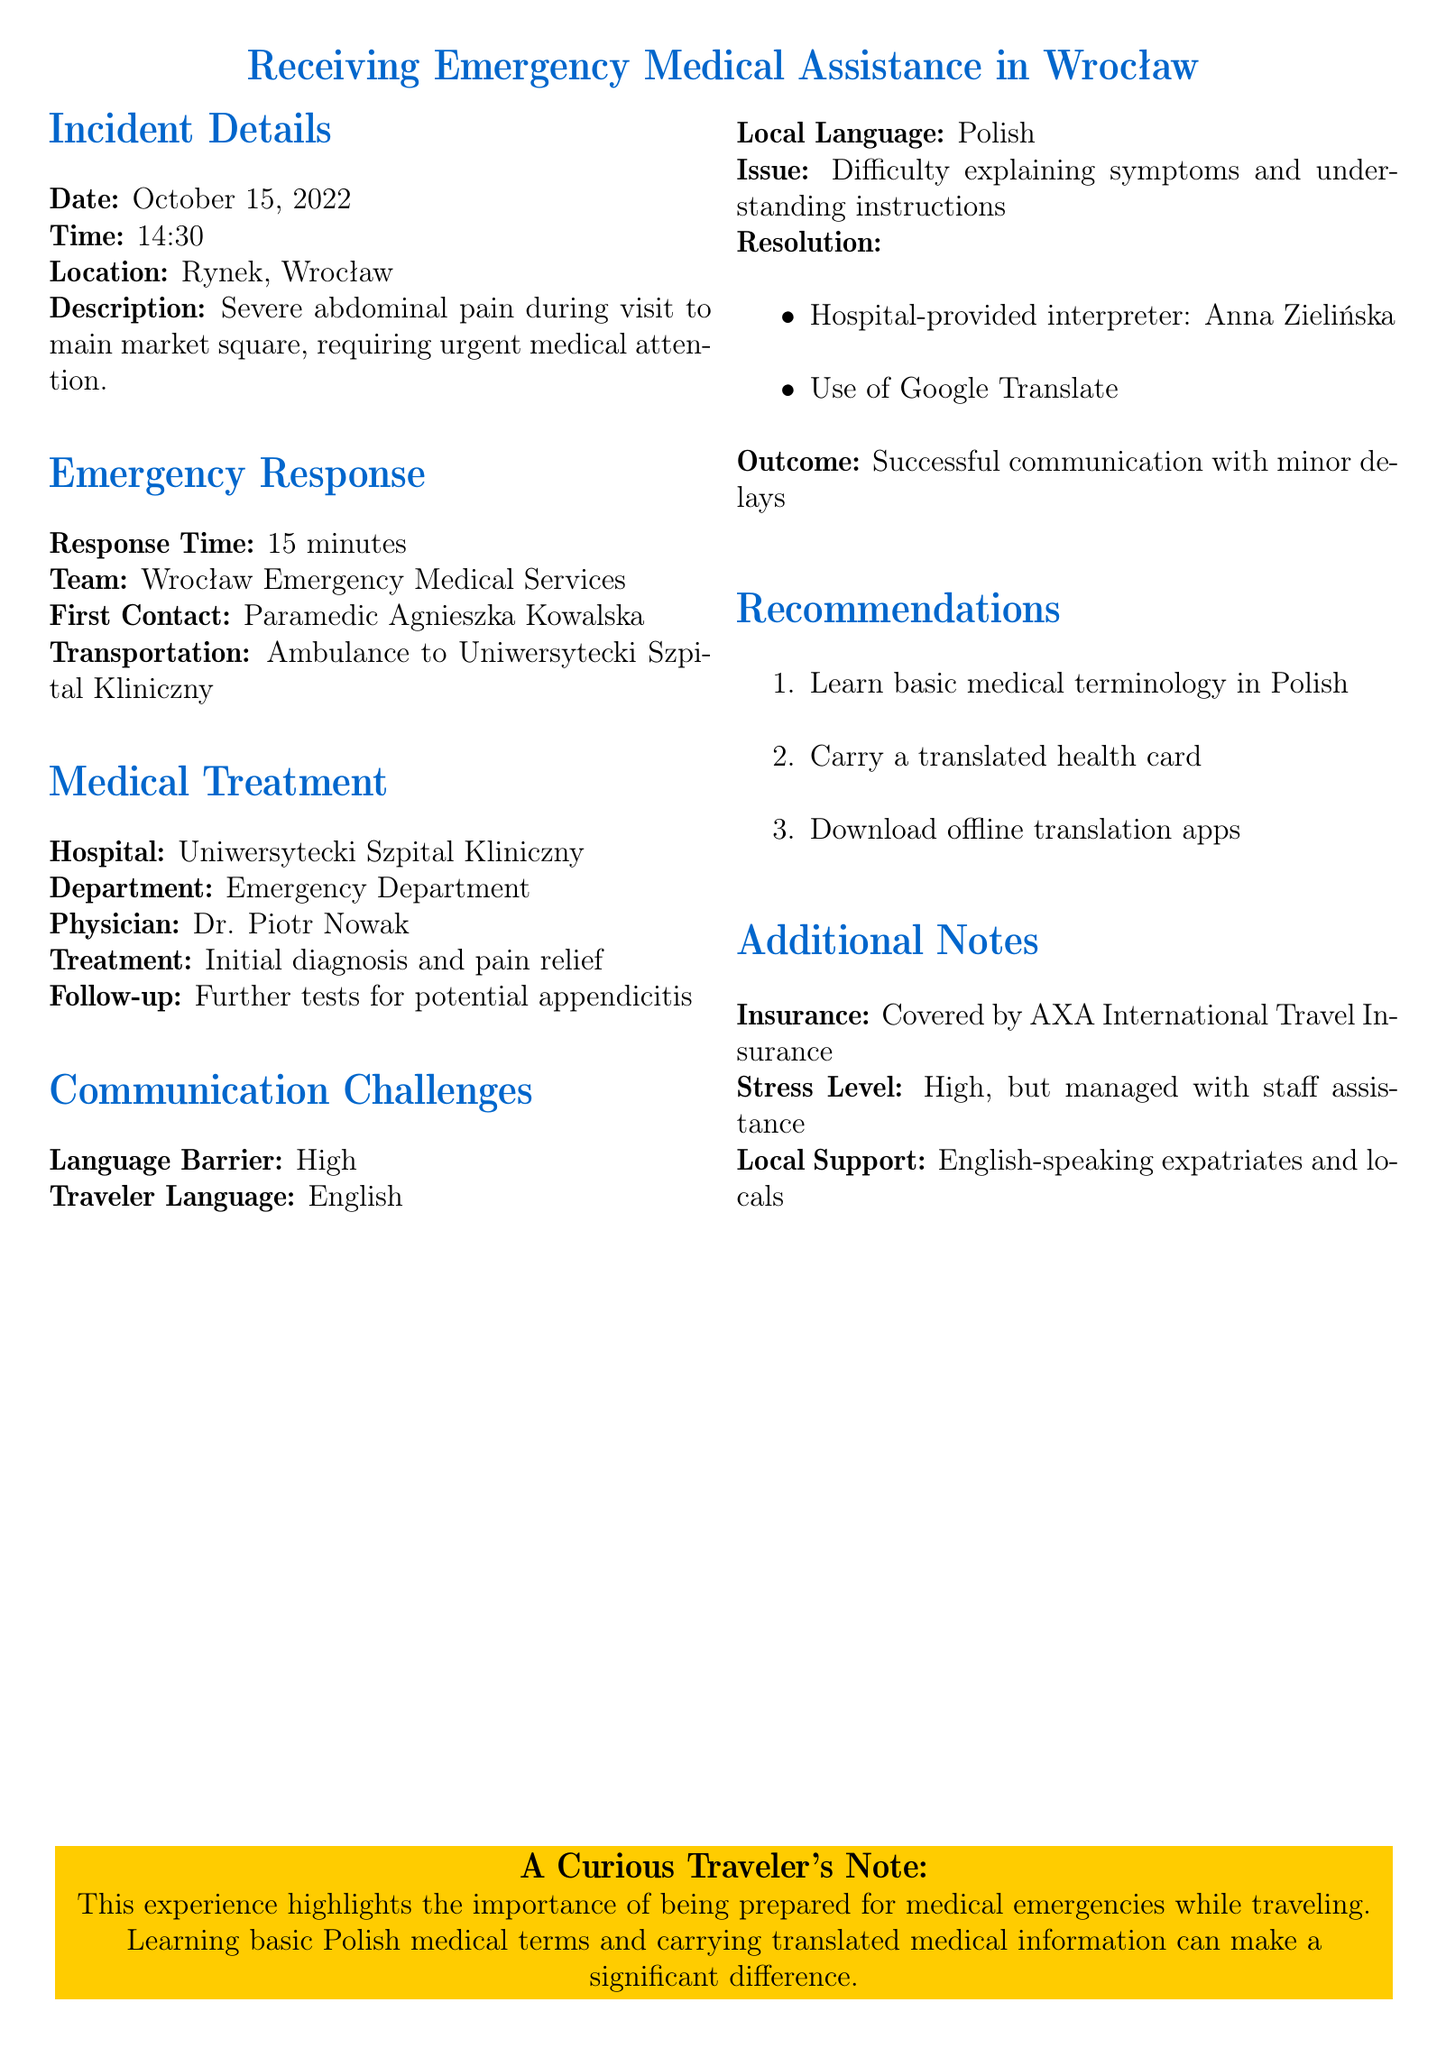What was the date of the incident? The date of the incident is explicitly stated in the document as October 15, 2022.
Answer: October 15, 2022 Who was the first contact paramedic? This information is indicated in the emergency response section, specifically naming the paramedic as Agnieszka Kowalska.
Answer: Agnieszka Kowalska What was the response time of the emergency services? The document states that the emergency response time was 15 minutes.
Answer: 15 minutes What language barrier was identified? The report describes the language barrier as "High," indicating significant challenges in communication.
Answer: High What treatment was given upon arrival at the hospital? The treatment received at the hospital included an initial diagnosis and pain relief as indicated in the medical treatment section.
Answer: Initial diagnosis and pain relief Why did the traveler experience communication difficulties? The difficulties arose due to the traveler speaking English while the locals spoke Polish, leading to challenges in explaining symptoms and understanding instructions.
Answer: Language Barrier How was the language barrier resolved? The resolution included the use of a hospital-provided interpreter and Google Translate, as detailed in the communication challenges section.
Answer: Interpreter and Google Translate What is one recommendation provided in the report? One recommendation includes learning basic medical terminology in Polish, which is mentioned in the recommendations section.
Answer: Learn basic medical terminology in Polish 